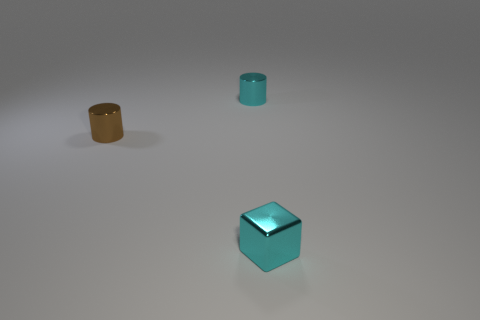What shape is the brown metallic object that is the same size as the metal cube? The brown metallic object that shares the same size as the metal cube is a cylinder. Its circular base and elongated shape are distinctly characteristic of a cylindrical object. 